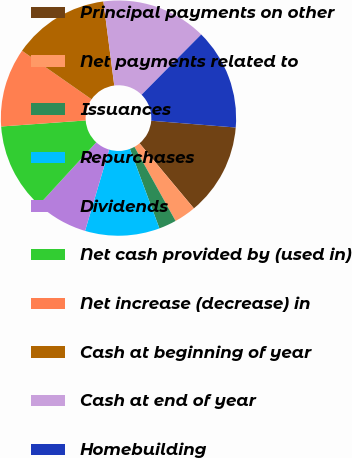Convert chart. <chart><loc_0><loc_0><loc_500><loc_500><pie_chart><fcel>Principal payments on other<fcel>Net payments related to<fcel>Issuances<fcel>Repurchases<fcel>Dividends<fcel>Net cash provided by (used in)<fcel>Net increase (decrease) in<fcel>Cash at beginning of year<fcel>Cash at end of year<fcel>Homebuilding<nl><fcel>12.65%<fcel>3.01%<fcel>2.41%<fcel>10.24%<fcel>7.23%<fcel>12.05%<fcel>10.84%<fcel>13.25%<fcel>14.46%<fcel>13.86%<nl></chart> 